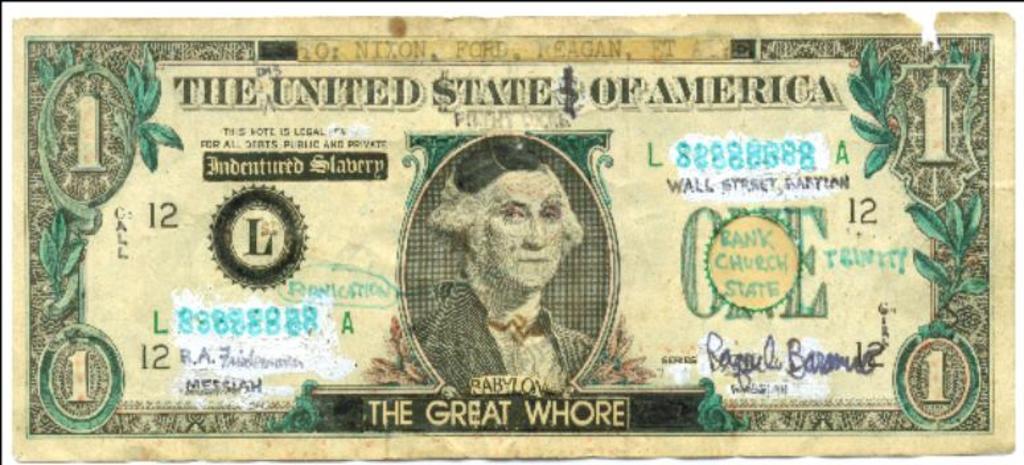How much money does the bill represent?
Provide a short and direct response. 1 dollar. 